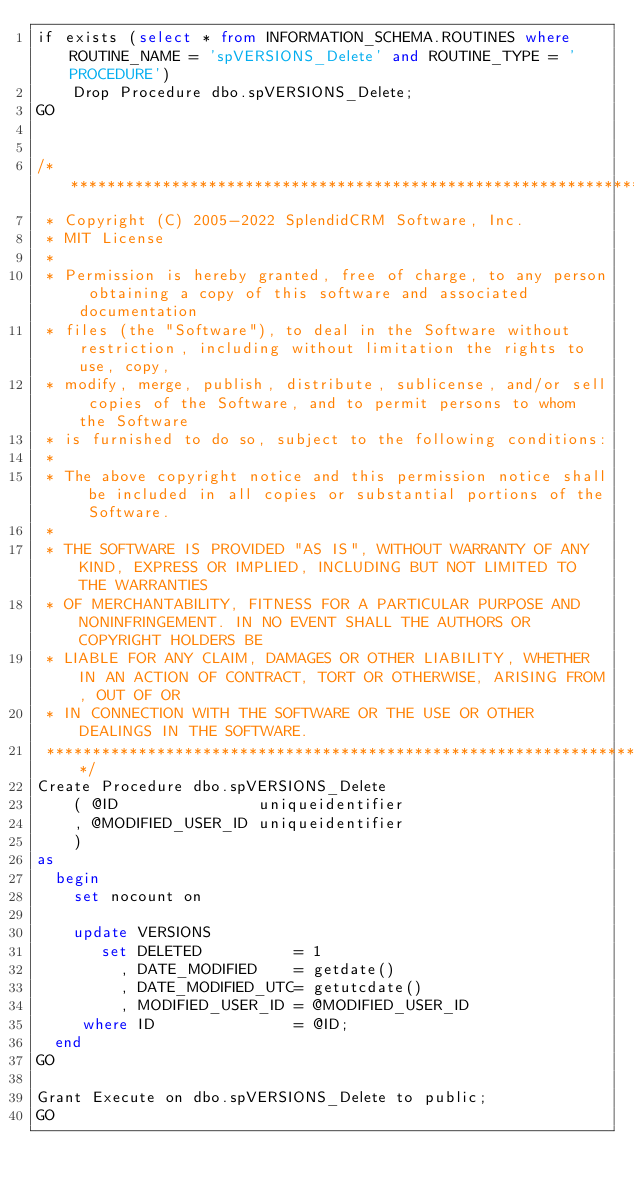<code> <loc_0><loc_0><loc_500><loc_500><_SQL_>if exists (select * from INFORMATION_SCHEMA.ROUTINES where ROUTINE_NAME = 'spVERSIONS_Delete' and ROUTINE_TYPE = 'PROCEDURE')
	Drop Procedure dbo.spVERSIONS_Delete;
GO


/**********************************************************************************************************************
 * Copyright (C) 2005-2022 SplendidCRM Software, Inc. 
 * MIT License
 * 
 * Permission is hereby granted, free of charge, to any person obtaining a copy of this software and associated documentation 
 * files (the "Software"), to deal in the Software without restriction, including without limitation the rights to use, copy, 
 * modify, merge, publish, distribute, sublicense, and/or sell copies of the Software, and to permit persons to whom the Software 
 * is furnished to do so, subject to the following conditions:
 * 
 * The above copyright notice and this permission notice shall be included in all copies or substantial portions of the Software.
 * 
 * THE SOFTWARE IS PROVIDED "AS IS", WITHOUT WARRANTY OF ANY KIND, EXPRESS OR IMPLIED, INCLUDING BUT NOT LIMITED TO THE WARRANTIES 
 * OF MERCHANTABILITY, FITNESS FOR A PARTICULAR PURPOSE AND NONINFRINGEMENT. IN NO EVENT SHALL THE AUTHORS OR COPYRIGHT HOLDERS BE 
 * LIABLE FOR ANY CLAIM, DAMAGES OR OTHER LIABILITY, WHETHER IN AN ACTION OF CONTRACT, TORT OR OTHERWISE, ARISING FROM, OUT OF OR 
 * IN CONNECTION WITH THE SOFTWARE OR THE USE OR OTHER DEALINGS IN THE SOFTWARE.
 *********************************************************************************************************************/
Create Procedure dbo.spVERSIONS_Delete
	( @ID               uniqueidentifier
	, @MODIFIED_USER_ID uniqueidentifier
	)
as
  begin
	set nocount on
	
	update VERSIONS
	   set DELETED          = 1
	     , DATE_MODIFIED    = getdate()
	     , DATE_MODIFIED_UTC= getutcdate()
	     , MODIFIED_USER_ID = @MODIFIED_USER_ID
	 where ID               = @ID;
  end
GO

Grant Execute on dbo.spVERSIONS_Delete to public;
GO


</code> 